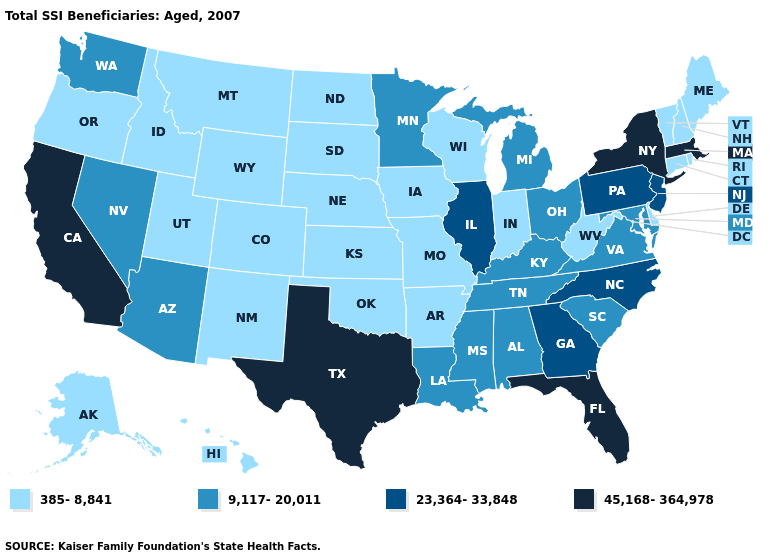Which states have the highest value in the USA?
Concise answer only. California, Florida, Massachusetts, New York, Texas. Name the states that have a value in the range 385-8,841?
Concise answer only. Alaska, Arkansas, Colorado, Connecticut, Delaware, Hawaii, Idaho, Indiana, Iowa, Kansas, Maine, Missouri, Montana, Nebraska, New Hampshire, New Mexico, North Dakota, Oklahoma, Oregon, Rhode Island, South Dakota, Utah, Vermont, West Virginia, Wisconsin, Wyoming. What is the lowest value in states that border Georgia?
Give a very brief answer. 9,117-20,011. What is the value of Oklahoma?
Answer briefly. 385-8,841. What is the value of Indiana?
Answer briefly. 385-8,841. What is the value of Georgia?
Write a very short answer. 23,364-33,848. What is the value of Georgia?
Quick response, please. 23,364-33,848. What is the lowest value in the West?
Answer briefly. 385-8,841. Name the states that have a value in the range 385-8,841?
Keep it brief. Alaska, Arkansas, Colorado, Connecticut, Delaware, Hawaii, Idaho, Indiana, Iowa, Kansas, Maine, Missouri, Montana, Nebraska, New Hampshire, New Mexico, North Dakota, Oklahoma, Oregon, Rhode Island, South Dakota, Utah, Vermont, West Virginia, Wisconsin, Wyoming. What is the value of West Virginia?
Answer briefly. 385-8,841. Which states have the lowest value in the USA?
Short answer required. Alaska, Arkansas, Colorado, Connecticut, Delaware, Hawaii, Idaho, Indiana, Iowa, Kansas, Maine, Missouri, Montana, Nebraska, New Hampshire, New Mexico, North Dakota, Oklahoma, Oregon, Rhode Island, South Dakota, Utah, Vermont, West Virginia, Wisconsin, Wyoming. What is the lowest value in states that border West Virginia?
Give a very brief answer. 9,117-20,011. What is the highest value in the MidWest ?
Give a very brief answer. 23,364-33,848. What is the value of California?
Quick response, please. 45,168-364,978. What is the value of Alaska?
Give a very brief answer. 385-8,841. 